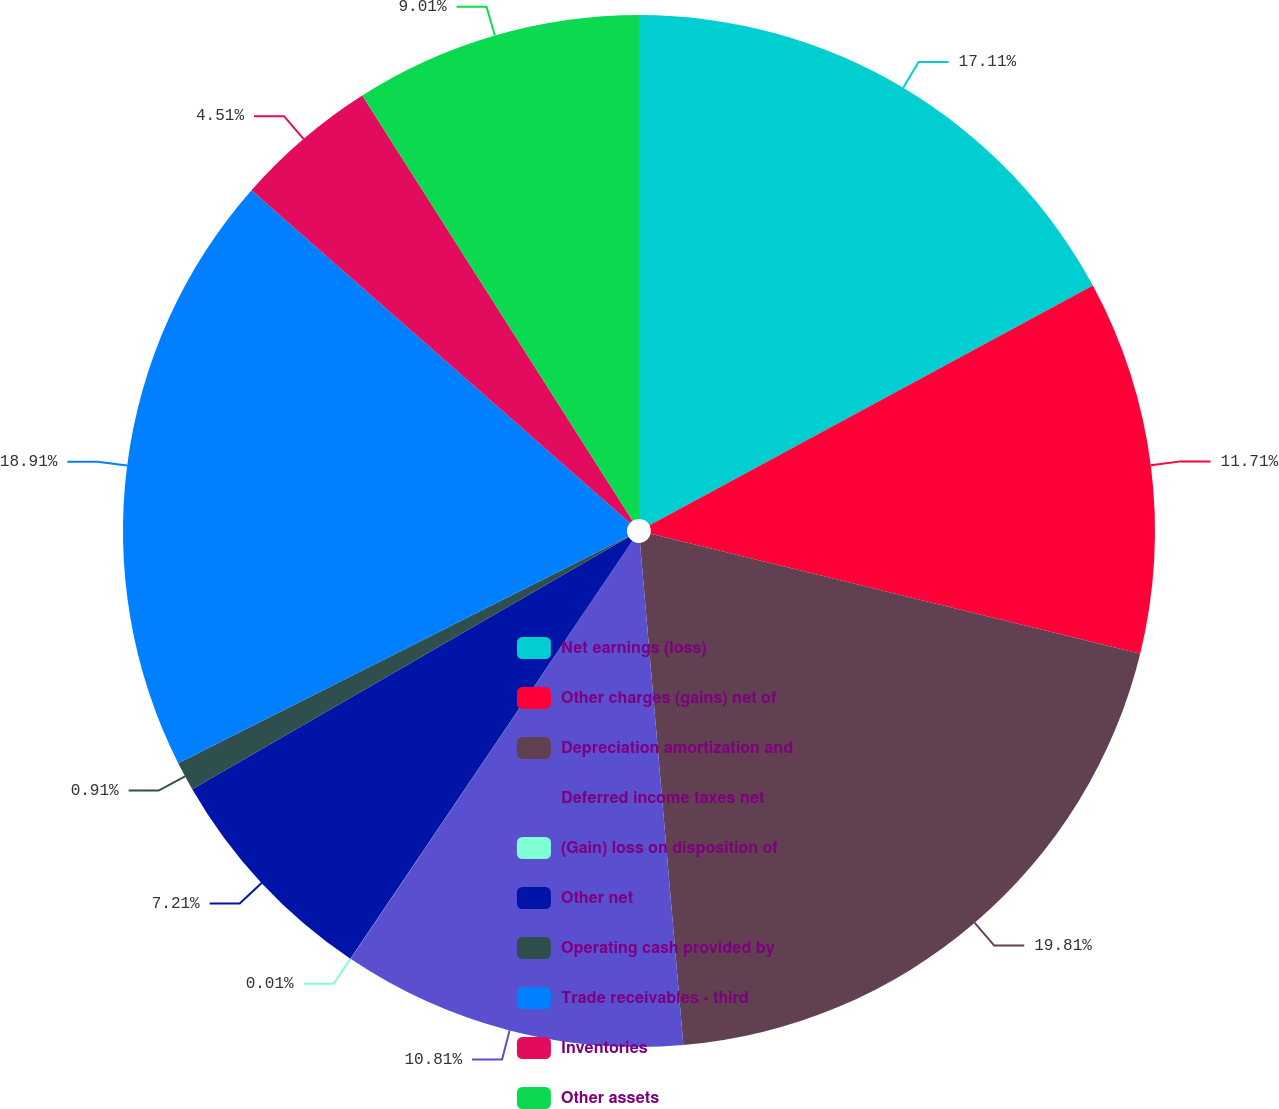Convert chart to OTSL. <chart><loc_0><loc_0><loc_500><loc_500><pie_chart><fcel>Net earnings (loss)<fcel>Other charges (gains) net of<fcel>Depreciation amortization and<fcel>Deferred income taxes net<fcel>(Gain) loss on disposition of<fcel>Other net<fcel>Operating cash provided by<fcel>Trade receivables - third<fcel>Inventories<fcel>Other assets<nl><fcel>17.11%<fcel>11.71%<fcel>19.81%<fcel>10.81%<fcel>0.01%<fcel>7.21%<fcel>0.91%<fcel>18.91%<fcel>4.51%<fcel>9.01%<nl></chart> 